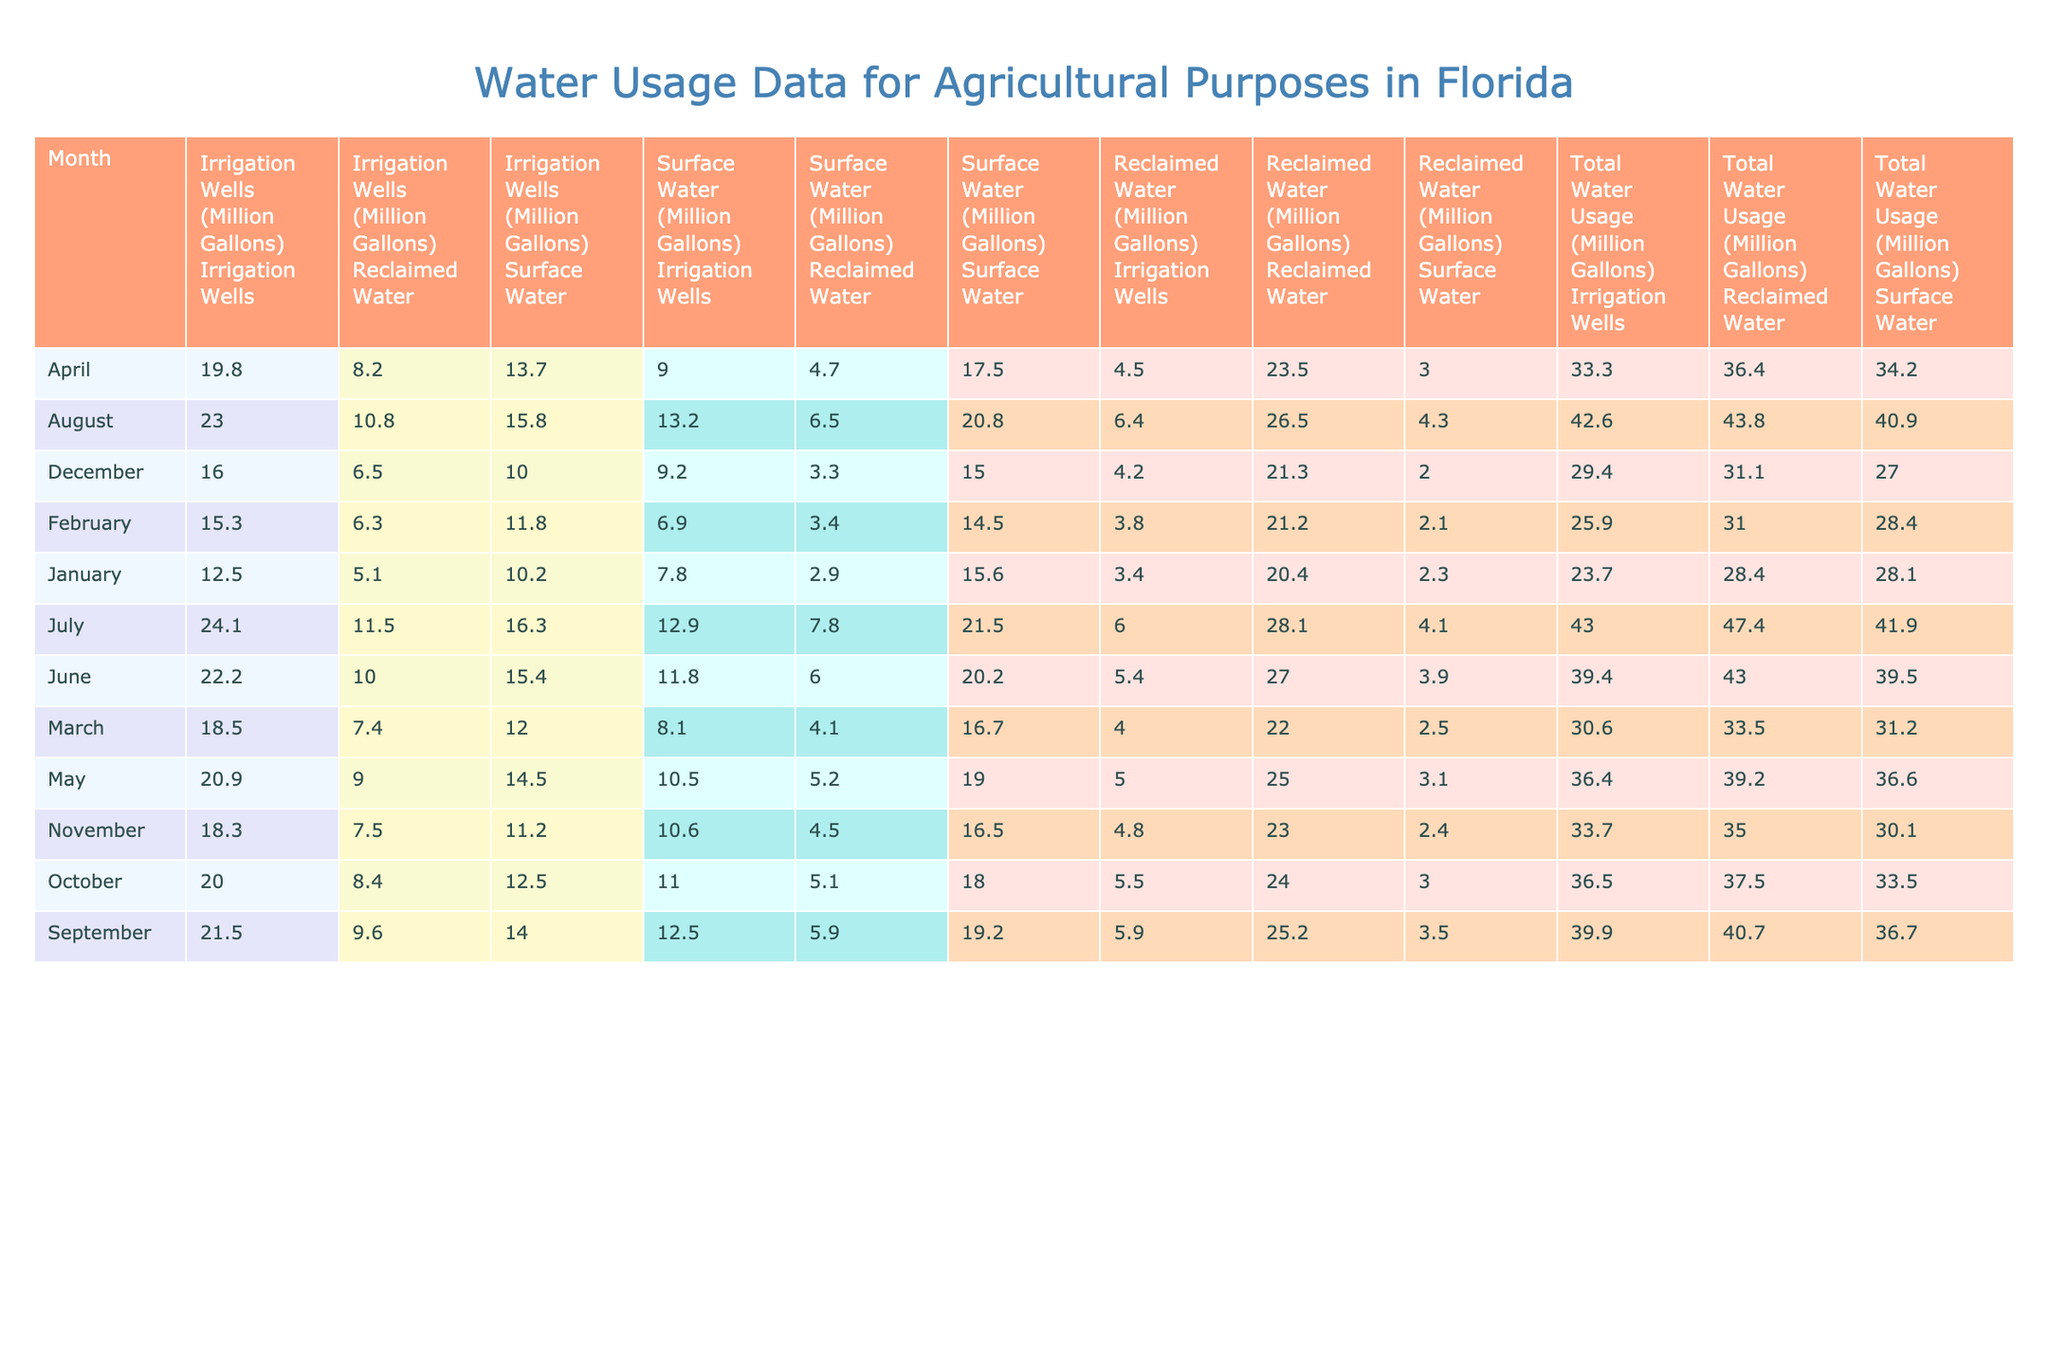What's the total water usage from reclaimed water in March? In March, the total water usage from reclaimed water is 33.5 million gallons, as indicated in the table.
Answer: 33.5 million gallons How much water was used from irrigation wells in July compared to June? In July, 43.0 million gallons were used from irrigation wells while in June it was 39.4 million gallons. The difference is 43.0 - 39.4 = 3.6 million gallons more in July.
Answer: 3.6 million gallons more Did the total water usage increase from January to December? The total water usage in January is 23.7 million gallons and in December, it is 31.1 million gallons. Since 31.1 is greater than 23.7, the total water usage increased over the year.
Answer: Yes What is the average total water usage for each month from January to March? To find the average, sum the total water usages from January (23.7), February (25.9), and March (30.6), which equals 80.2 million gallons. Then divide by 3 months: 80.2 / 3 ≈ 26.73 million gallons.
Answer: Approximately 26.73 million gallons Which month had the highest usage of surface water? By examining the table, July shows the highest surface water usage at 21.5 million gallons.
Answer: July What was the percentage increase in surface water usage from April to May? In April, the surface water usage was 17.5 million gallons, and in May it increased to 19.0 million gallons. The difference is 19.0 - 17.5 = 1.5 million gallons. The percentage increase is (1.5 / 17.5) * 100 ≈ 8.57%.
Answer: Approximately 8.57% How does the total water usage in October compare to that in September? In October, the total water usage is 33.5 million gallons, while in September it's 36.7 million gallons. Therefore, October has 36.7 - 33.5 = 3.2 million gallons less total water usage.
Answer: 3.2 million gallons less Which source had the highest total water usage across all months? By comparing the totals from all sources, reclaim water consistently has higher usages compared to irrigation wells and surface water. The largest single month for reclaimed water is June with 43.0 million gallons.
Answer: Reclaimed Water What is the difference in water usage from irrigation wells between January and April? In January, the irrigation wells used 23.7 million gallons and in April, it used 33.3 million gallons. The increase is 33.3 - 23.7 = 9.6 million gallons.
Answer: 9.6 million gallons more Which month saw the lowest total water usage? January had the lowest total water usage at 23.7 million gallons.
Answer: January What is the total water usage from all sources combined in August? In August, the total water usage amounts to 42.6 + 40.9 + 43.8 = 127.3 million gallons combined from all sources.
Answer: 127.3 million gallons 